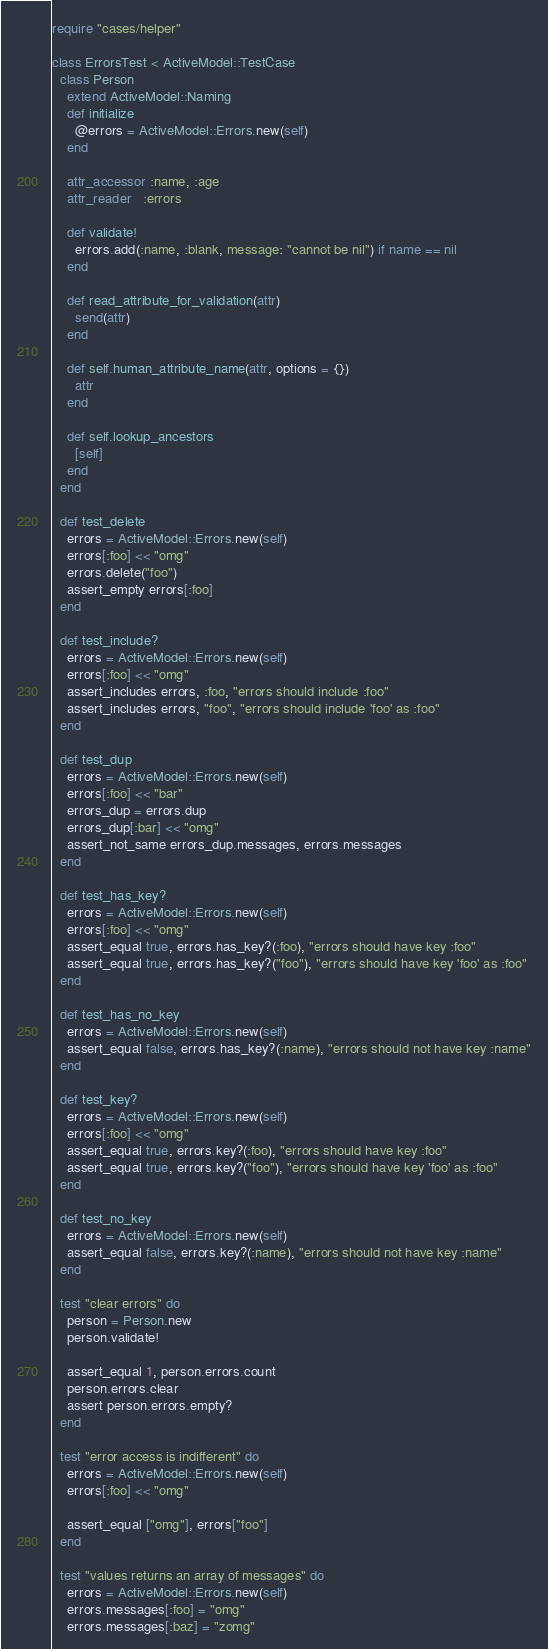<code> <loc_0><loc_0><loc_500><loc_500><_Ruby_>require "cases/helper"

class ErrorsTest < ActiveModel::TestCase
  class Person
    extend ActiveModel::Naming
    def initialize
      @errors = ActiveModel::Errors.new(self)
    end

    attr_accessor :name, :age
    attr_reader   :errors

    def validate!
      errors.add(:name, :blank, message: "cannot be nil") if name == nil
    end

    def read_attribute_for_validation(attr)
      send(attr)
    end

    def self.human_attribute_name(attr, options = {})
      attr
    end

    def self.lookup_ancestors
      [self]
    end
  end

  def test_delete
    errors = ActiveModel::Errors.new(self)
    errors[:foo] << "omg"
    errors.delete("foo")
    assert_empty errors[:foo]
  end

  def test_include?
    errors = ActiveModel::Errors.new(self)
    errors[:foo] << "omg"
    assert_includes errors, :foo, "errors should include :foo"
    assert_includes errors, "foo", "errors should include 'foo' as :foo"
  end

  def test_dup
    errors = ActiveModel::Errors.new(self)
    errors[:foo] << "bar"
    errors_dup = errors.dup
    errors_dup[:bar] << "omg"
    assert_not_same errors_dup.messages, errors.messages
  end

  def test_has_key?
    errors = ActiveModel::Errors.new(self)
    errors[:foo] << "omg"
    assert_equal true, errors.has_key?(:foo), "errors should have key :foo"
    assert_equal true, errors.has_key?("foo"), "errors should have key 'foo' as :foo"
  end

  def test_has_no_key
    errors = ActiveModel::Errors.new(self)
    assert_equal false, errors.has_key?(:name), "errors should not have key :name"
  end

  def test_key?
    errors = ActiveModel::Errors.new(self)
    errors[:foo] << "omg"
    assert_equal true, errors.key?(:foo), "errors should have key :foo"
    assert_equal true, errors.key?("foo"), "errors should have key 'foo' as :foo"
  end

  def test_no_key
    errors = ActiveModel::Errors.new(self)
    assert_equal false, errors.key?(:name), "errors should not have key :name"
  end

  test "clear errors" do
    person = Person.new
    person.validate!

    assert_equal 1, person.errors.count
    person.errors.clear
    assert person.errors.empty?
  end

  test "error access is indifferent" do
    errors = ActiveModel::Errors.new(self)
    errors[:foo] << "omg"

    assert_equal ["omg"], errors["foo"]
  end

  test "values returns an array of messages" do
    errors = ActiveModel::Errors.new(self)
    errors.messages[:foo] = "omg"
    errors.messages[:baz] = "zomg"
</code> 